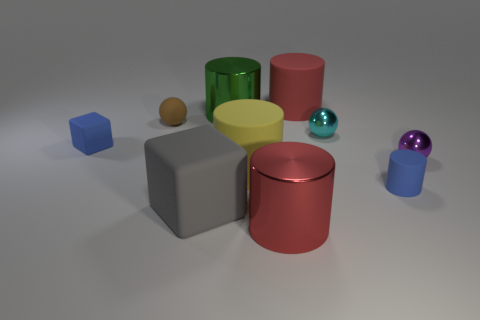What material do the various objects in the image seem to be made of? The objects appear to be made of different materials. The cylinders and spheres likely represent materials such as metal or plastic, given their shiny appearance. The cube and the bigger matte cylinder seem to embody a matte surface, possibly signifying a substance like stone or unglazed ceramic. 